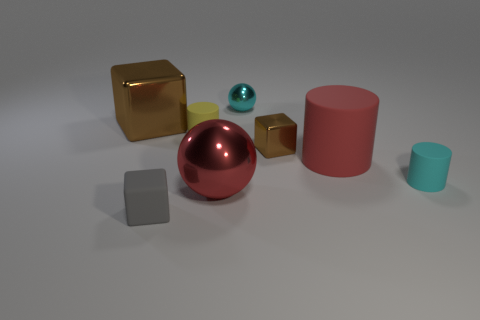Add 2 matte blocks. How many objects exist? 10 Subtract all blue cubes. Subtract all cyan balls. How many cubes are left? 3 Subtract all balls. How many objects are left? 6 Add 1 small cylinders. How many small cylinders exist? 3 Subtract 1 yellow cylinders. How many objects are left? 7 Subtract all large purple rubber balls. Subtract all red rubber things. How many objects are left? 7 Add 7 tiny gray rubber cubes. How many tiny gray rubber cubes are left? 8 